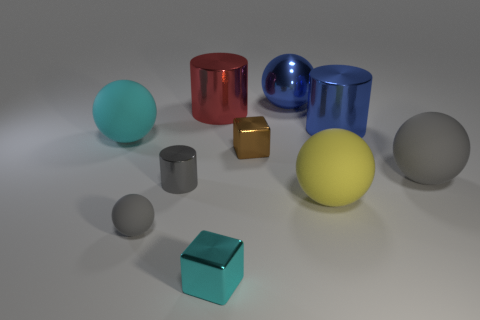What colors are the spheres in the image? The spheres in the image feature a variety of colors, including blue, yellow, grey, and teal. Which is the largest sphere and what color is it? The largest sphere appears to be the blue one centrally located in the image. 